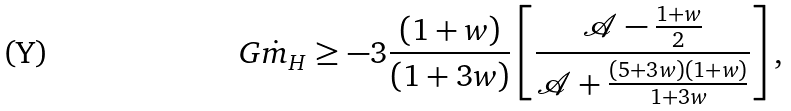<formula> <loc_0><loc_0><loc_500><loc_500>G \dot { m } _ { H } \geq - 3 \frac { \left ( 1 + w \right ) } { \left ( 1 + 3 w \right ) } \left [ \frac { \mathcal { A } - \frac { 1 + w } { 2 } } { \mathcal { A } + \frac { \left ( 5 + 3 w \right ) \left ( 1 + w \right ) } { 1 + 3 w } } \right ] ,</formula> 